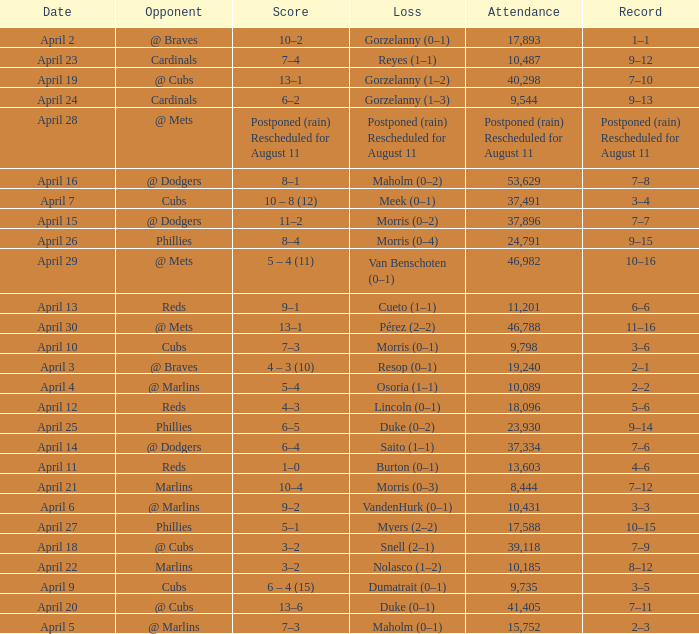What opponent had an attendance of 10,089? @ Marlins. 